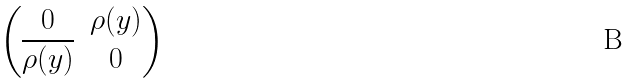<formula> <loc_0><loc_0><loc_500><loc_500>\begin{pmatrix} 0 & \rho ( y ) \\ \overline { \rho ( y ) } & 0 \end{pmatrix}</formula> 